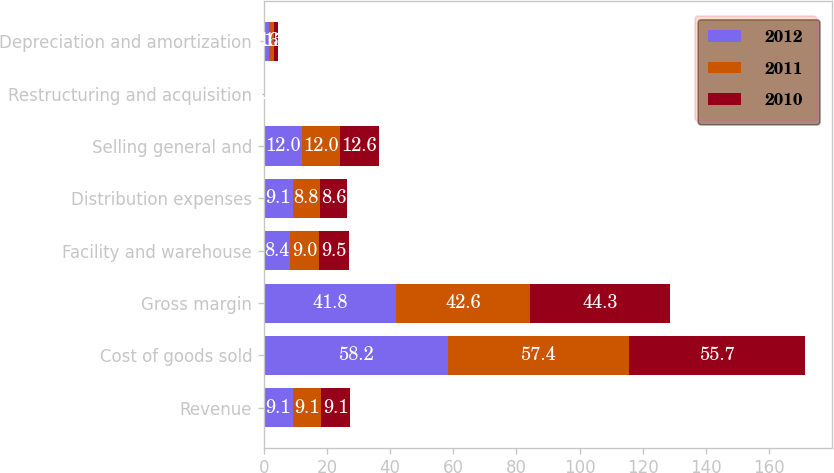Convert chart. <chart><loc_0><loc_0><loc_500><loc_500><stacked_bar_chart><ecel><fcel>Revenue<fcel>Cost of goods sold<fcel>Gross margin<fcel>Facility and warehouse<fcel>Distribution expenses<fcel>Selling general and<fcel>Restructuring and acquisition<fcel>Depreciation and amortization<nl><fcel>2012<fcel>9.1<fcel>58.2<fcel>41.8<fcel>8.4<fcel>9.1<fcel>12<fcel>0.1<fcel>1.6<nl><fcel>2011<fcel>9.1<fcel>57.4<fcel>42.6<fcel>9<fcel>8.8<fcel>12<fcel>0.2<fcel>1.5<nl><fcel>2010<fcel>9.1<fcel>55.7<fcel>44.3<fcel>9.5<fcel>8.6<fcel>12.6<fcel>0<fcel>1.5<nl></chart> 